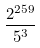Convert formula to latex. <formula><loc_0><loc_0><loc_500><loc_500>\frac { 2 ^ { 2 5 9 } } { 5 ^ { 3 } }</formula> 